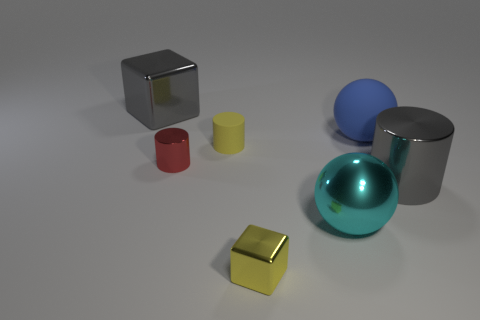I see different geometrical shapes, can you name them? Of course. There are several geometric shapes: a cylinder, a cube, a sphere, and what appears to be rectangular boxes, one of which is smaller and the other appears larger and partially obscured behind the cylinder.  Are there any other details about the shapes that stand out? Indeed, each shape has distinct properties. The sphere has a reflective surface, the cube looks metallic, and the cylinder has a smooth, matte finish. The varying sizes and colors also give each shape a unique presence in the arrangement. 